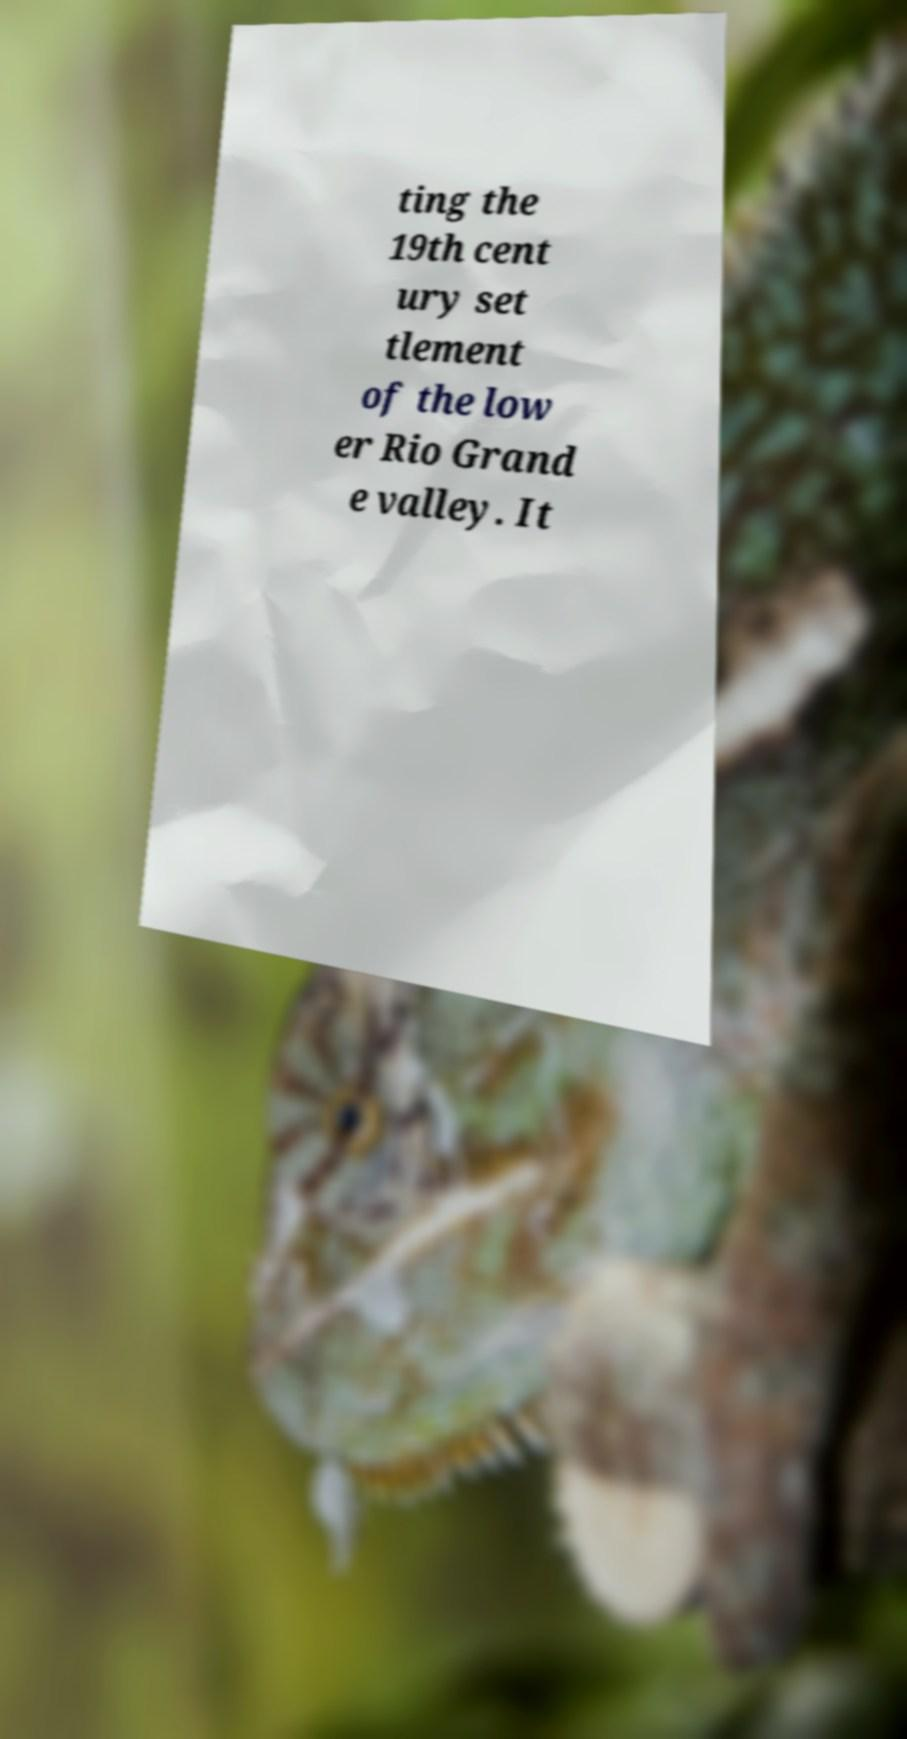Please read and relay the text visible in this image. What does it say? ting the 19th cent ury set tlement of the low er Rio Grand e valley. It 